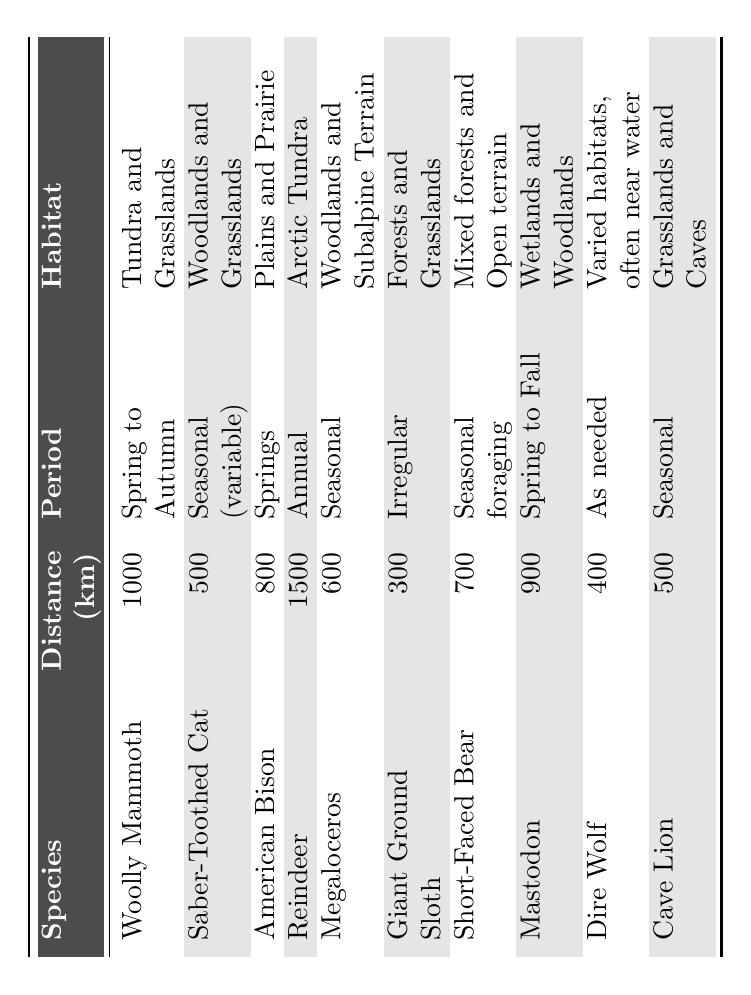What is the migration distance of the Woolly Mammoth? The table shows that the Woolly Mammoth has a migration distance of 1000 km listed in the corresponding row.
Answer: 1000 km Which species migrates the shortest distance? By comparing the migration distances of all species, the Giant Ground Sloth has the shortest distance at 300 km.
Answer: 300 km How many species migrate during the spring season? The table indicates that the Woolly Mammoth, American Bison, and Mastodon migrate during spring or springto autumn, totaling three species.
Answer: 3 What habitat does the Reindeer inhabit? The Reindeer is noted in the table to occupy the Arctic Tundra.
Answer: Arctic Tundra Which species has the longest migration period? The Reindeer has an annual migration period, which is longer compared to other species with limited migration periods listed.
Answer: Annual What is the average migration distance of all species listed? The total migration distances are (1000 + 500 + 800 + 1500 + 600 + 300 + 700 + 900 + 400 + 500) = 5100 km, and there are 10 species, so the average is 5100 km / 10 = 510 km.
Answer: 510 km Is it true that the Saber-Toothed Cat migrates 600 km? In the table, the Saber-Toothed Cat's distance is shown as 500 km, so this statement is false.
Answer: No Which species migrates for seasonal foraging? The table states that the Short-Faced Bear migrates for seasonal foraging as listed in its row.
Answer: Short-Faced Bear Which two species have the same migration distance of 500 km? Both the Saber-Toothed Cat and the Cave Lion have the same migration distance of 500 km as indicated in the table.
Answer: Saber-Toothed Cat and Cave Lion What is the difference in migration distance between the Reindeer and the Giant Ground Sloth? The Reindeer migrates 1500 km and the Giant Ground Sloth migrates 300 km, so the difference is 1500 km - 300 km = 1200 km.
Answer: 1200 km 